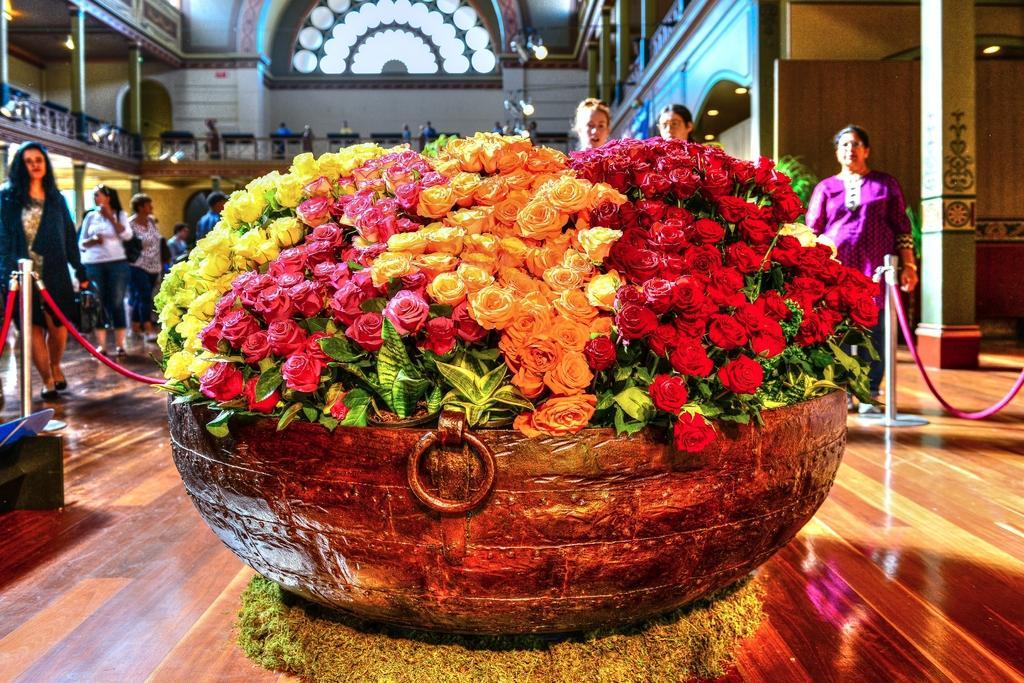Please provide a concise description of this image. In the picture we can see a bunch of flowers with plants in the bowl and placed on the wooden floor, and besides to it, we can see a railing with wires and poles and some people walking on the floor in the palace and we can see some pillars with floor and some lights. 